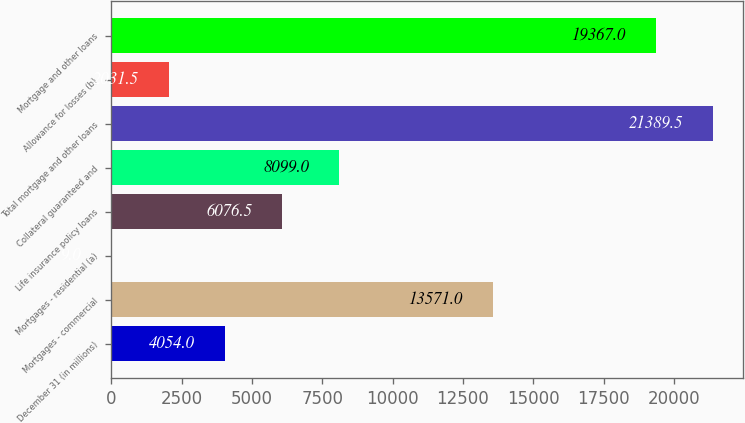Convert chart. <chart><loc_0><loc_0><loc_500><loc_500><bar_chart><fcel>December 31 (in millions)<fcel>Mortgages - commercial<fcel>Mortgages - residential (a)<fcel>Life insurance policy loans<fcel>Collateral guaranteed and<fcel>Total mortgage and other loans<fcel>Allowance for losses (b)<fcel>Mortgage and other loans<nl><fcel>4054<fcel>13571<fcel>9<fcel>6076.5<fcel>8099<fcel>21389.5<fcel>2031.5<fcel>19367<nl></chart> 